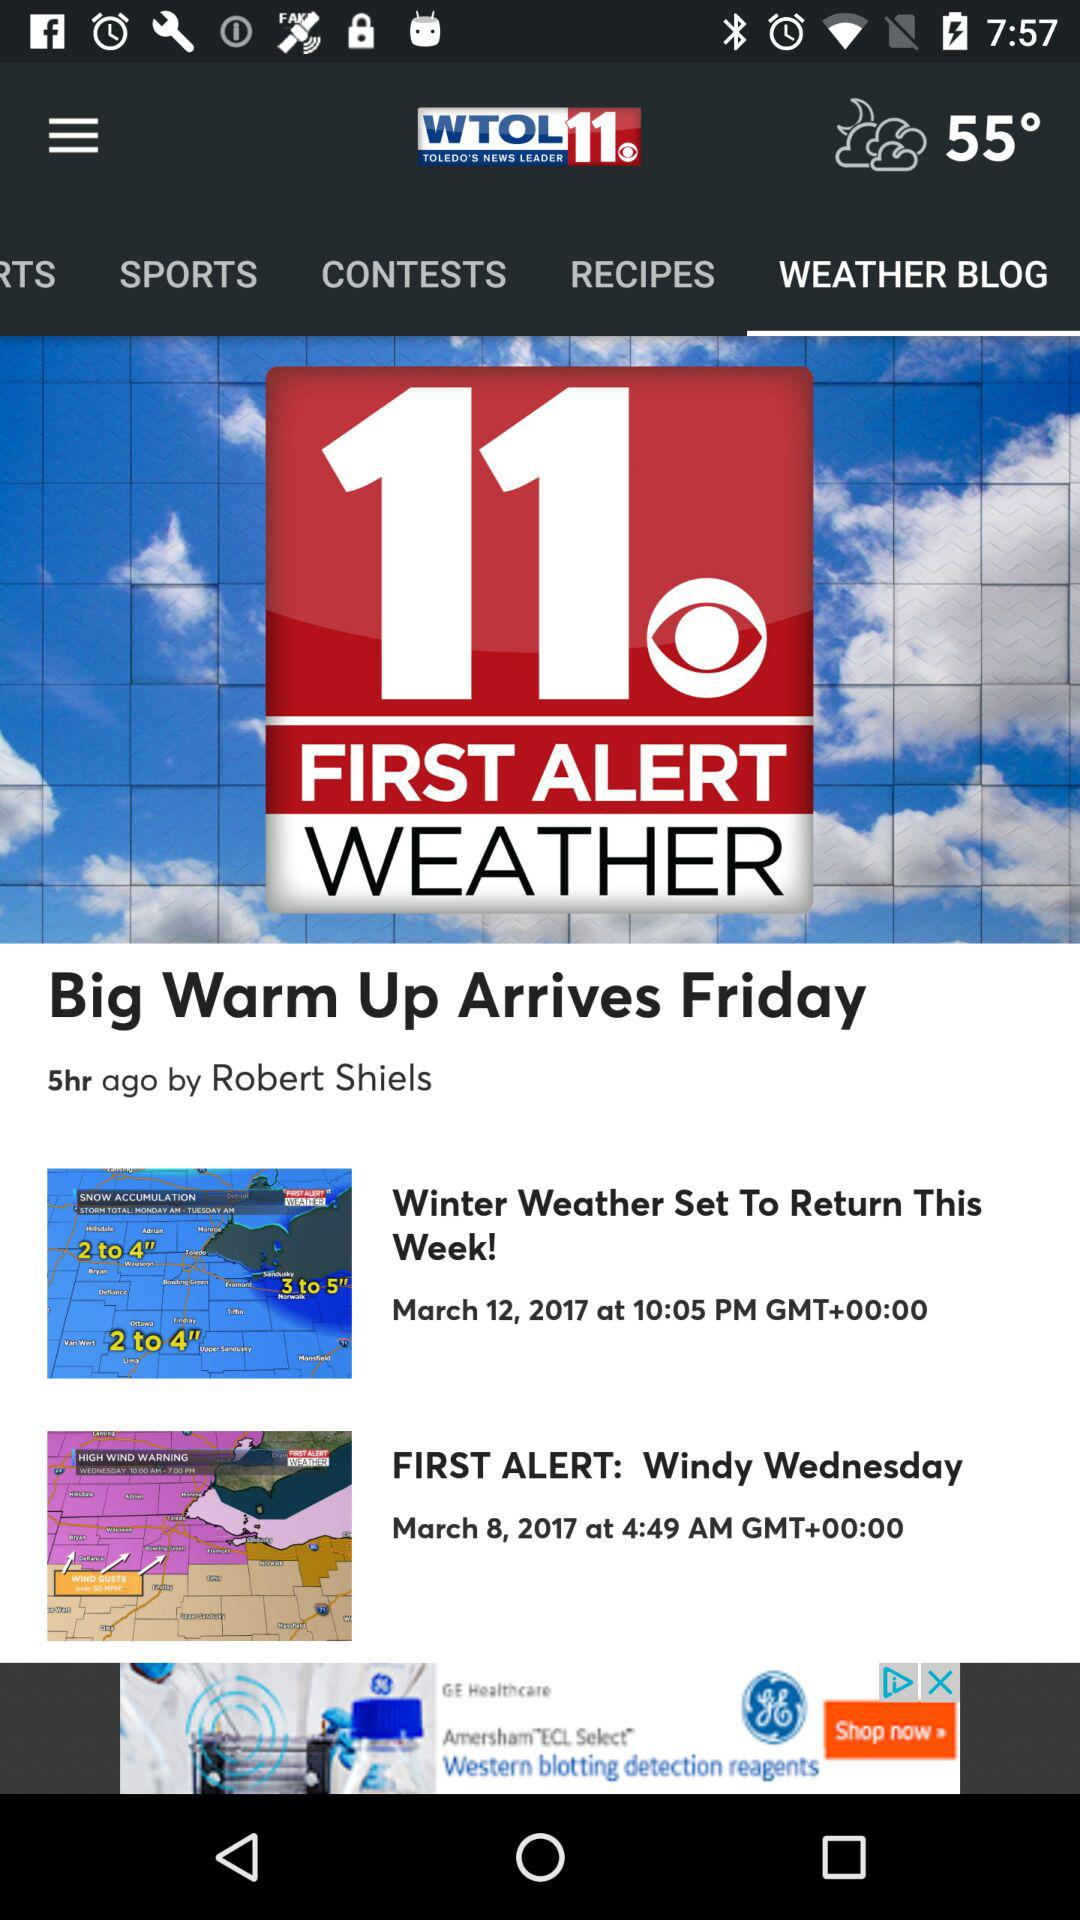Who posted the article "Big Warm Up Arrives Friday"? The article was posted by Robert Shiels. 